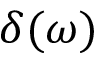Convert formula to latex. <formula><loc_0><loc_0><loc_500><loc_500>\delta ( \omega )</formula> 